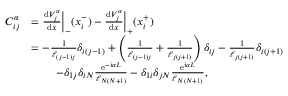<formula> <loc_0><loc_0><loc_500><loc_500>\begin{array} { r l } { C _ { i j } ^ { \alpha } } & { = \frac { d V _ { j } ^ { \alpha } } { d x } \left | _ { - } ( x _ { i } ^ { - } ) - \frac { d V _ { j } ^ { \alpha } } { d x } \right | _ { + } ( x _ { i } ^ { + } ) } \\ & { = - \frac { 1 } { \ell _ { ( j - 1 ) j } } \delta _ { i ( j - 1 ) } + \left ( \frac { 1 } { \ell _ { ( j - 1 ) j } } + \frac { 1 } { \ell _ { j ( j + 1 ) } } \right ) \delta _ { i j } - \frac { 1 } { \ell _ { j ( j + 1 ) } } \delta _ { i ( j + 1 ) } } \\ & { \, \quad - \delta _ { 1 j } \delta _ { i N } \frac { e ^ { - i \alpha L } } { \ell _ { N ( N + 1 ) } } - \delta _ { 1 i } \delta _ { j N } \frac { e ^ { i \alpha L } } { \ell _ { N ( N + 1 ) } } , } \end{array}</formula> 